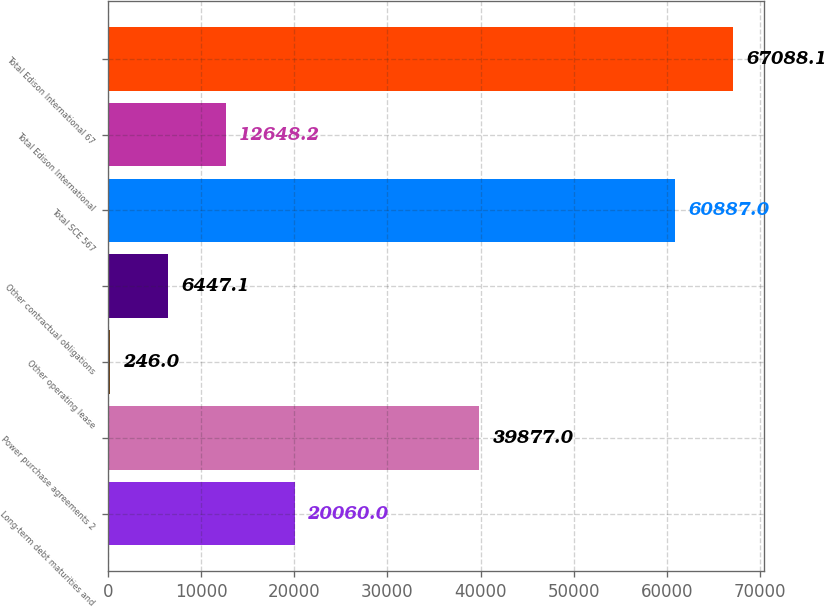Convert chart to OTSL. <chart><loc_0><loc_0><loc_500><loc_500><bar_chart><fcel>Long-term debt maturities and<fcel>Power purchase agreements 2<fcel>Other operating lease<fcel>Other contractual obligations<fcel>Total SCE 567<fcel>Total Edison International<fcel>Total Edison International 67<nl><fcel>20060<fcel>39877<fcel>246<fcel>6447.1<fcel>60887<fcel>12648.2<fcel>67088.1<nl></chart> 